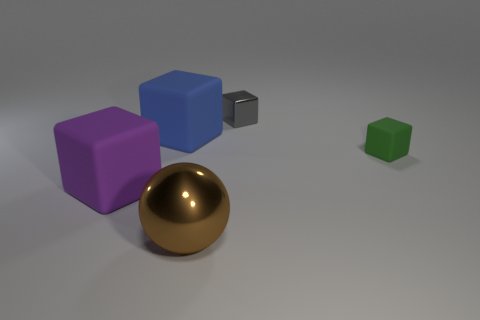Subtract all matte blocks. How many blocks are left? 1 Add 2 big blue matte cubes. How many objects exist? 7 Subtract all purple blocks. How many blocks are left? 3 Subtract 1 balls. How many balls are left? 0 Add 2 small purple matte cylinders. How many small purple matte cylinders exist? 2 Subtract 0 cyan cylinders. How many objects are left? 5 Subtract all cubes. How many objects are left? 1 Subtract all purple spheres. Subtract all green cylinders. How many spheres are left? 1 Subtract all large gray matte objects. Subtract all metallic things. How many objects are left? 3 Add 5 blue matte blocks. How many blue matte blocks are left? 6 